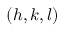Convert formula to latex. <formula><loc_0><loc_0><loc_500><loc_500>( h , k , l )</formula> 